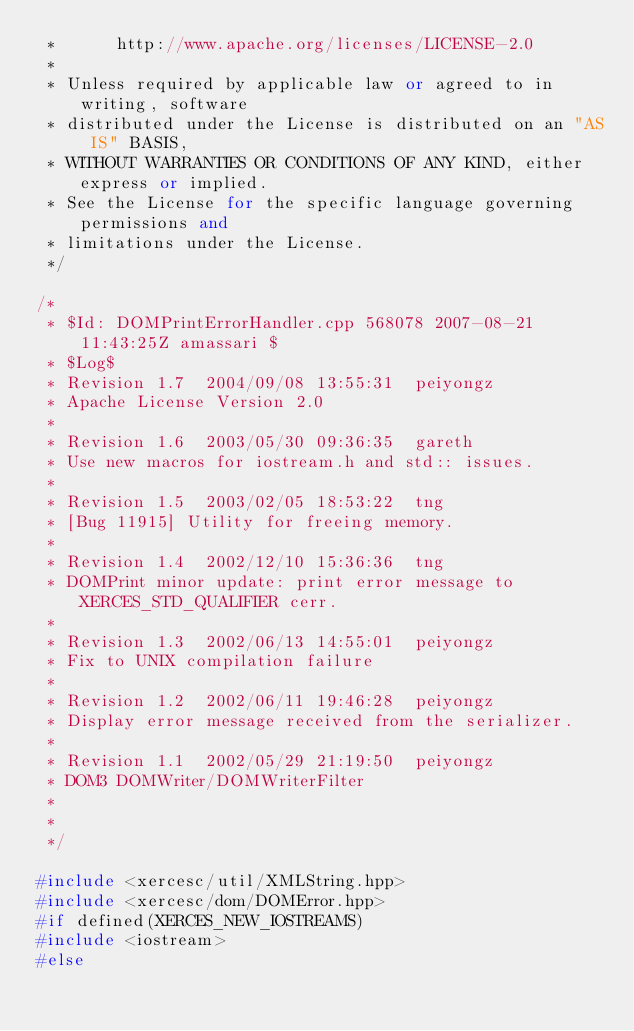Convert code to text. <code><loc_0><loc_0><loc_500><loc_500><_C++_> *      http://www.apache.org/licenses/LICENSE-2.0
 * 
 * Unless required by applicable law or agreed to in writing, software
 * distributed under the License is distributed on an "AS IS" BASIS,
 * WITHOUT WARRANTIES OR CONDITIONS OF ANY KIND, either express or implied.
 * See the License for the specific language governing permissions and
 * limitations under the License.
 */

/*
 * $Id: DOMPrintErrorHandler.cpp 568078 2007-08-21 11:43:25Z amassari $
 * $Log$
 * Revision 1.7  2004/09/08 13:55:31  peiyongz
 * Apache License Version 2.0
 *
 * Revision 1.6  2003/05/30 09:36:35  gareth
 * Use new macros for iostream.h and std:: issues.
 *
 * Revision 1.5  2003/02/05 18:53:22  tng
 * [Bug 11915] Utility for freeing memory.
 *
 * Revision 1.4  2002/12/10 15:36:36  tng
 * DOMPrint minor update: print error message to XERCES_STD_QUALIFIER cerr.
 *
 * Revision 1.3  2002/06/13 14:55:01  peiyongz
 * Fix to UNIX compilation failure
 *
 * Revision 1.2  2002/06/11 19:46:28  peiyongz
 * Display error message received from the serializer.
 *
 * Revision 1.1  2002/05/29 21:19:50  peiyongz
 * DOM3 DOMWriter/DOMWriterFilter
 *
 *
 */

#include <xercesc/util/XMLString.hpp>
#include <xercesc/dom/DOMError.hpp>
#if defined(XERCES_NEW_IOSTREAMS)
#include <iostream>
#else</code> 